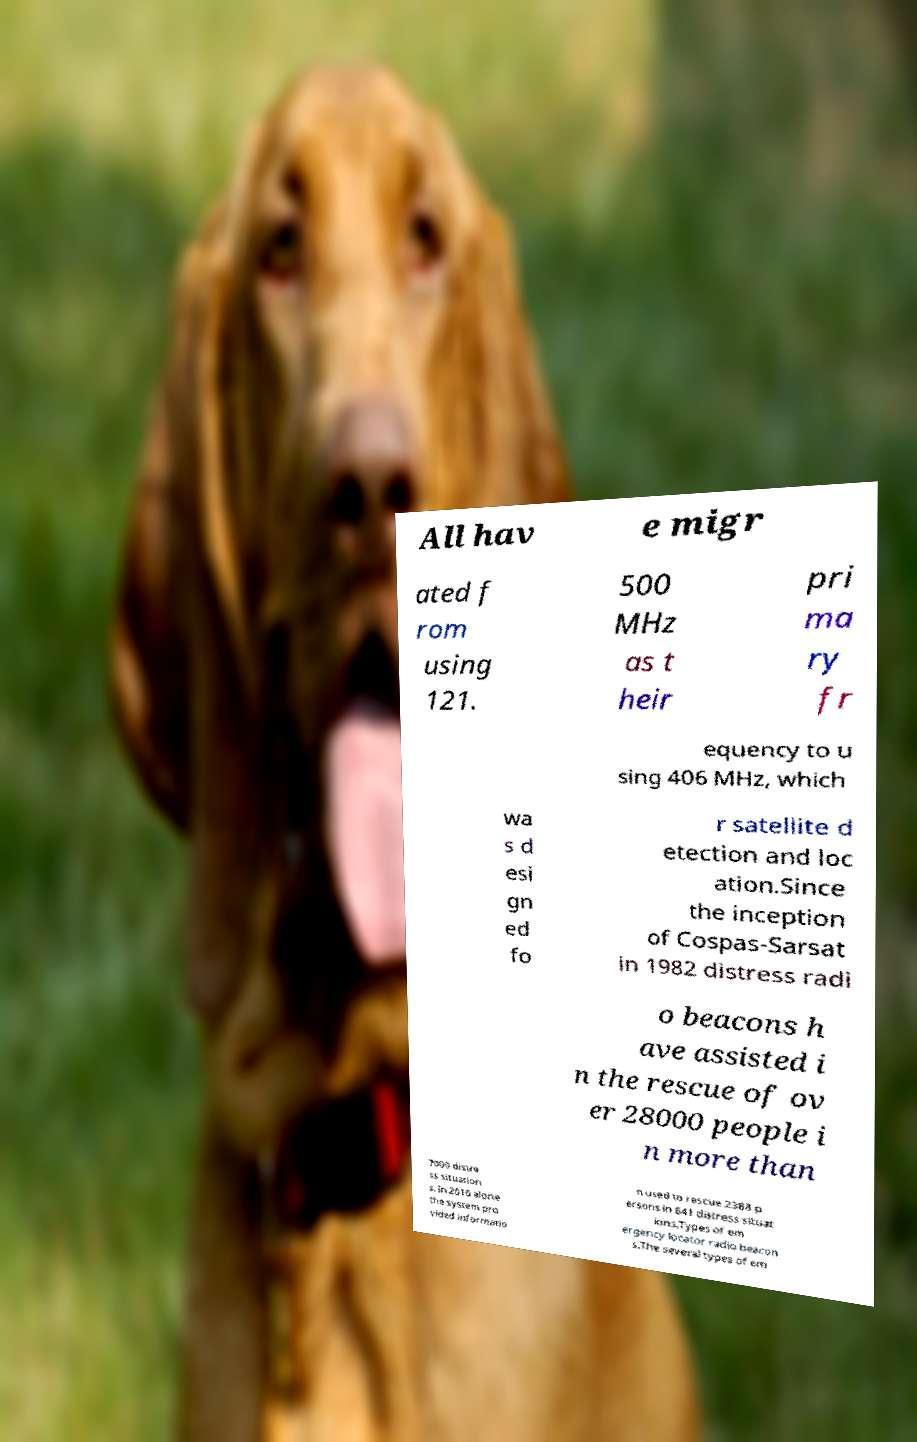Could you assist in decoding the text presented in this image and type it out clearly? All hav e migr ated f rom using 121. 500 MHz as t heir pri ma ry fr equency to u sing 406 MHz, which wa s d esi gn ed fo r satellite d etection and loc ation.Since the inception of Cospas-Sarsat in 1982 distress radi o beacons h ave assisted i n the rescue of ov er 28000 people i n more than 7000 distre ss situation s. In 2010 alone the system pro vided informatio n used to rescue 2388 p ersons in 641 distress situat ions.Types of em ergency locator radio beacon s.The several types of em 